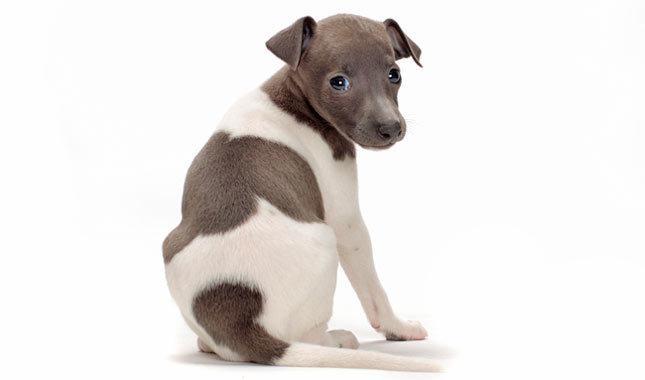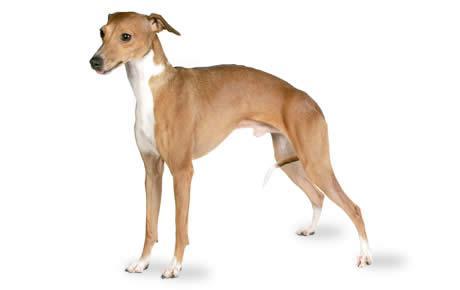The first image is the image on the left, the second image is the image on the right. Analyze the images presented: Is the assertion "One image shows a light brown dog standing." valid? Answer yes or no. Yes. 